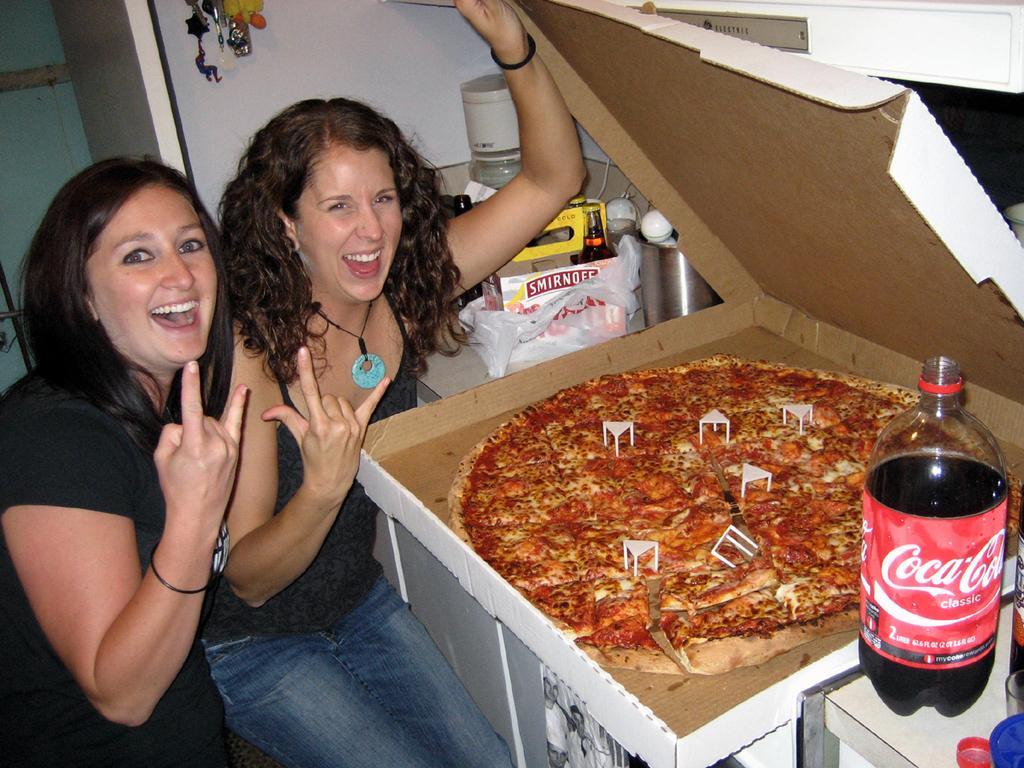Can you describe this image briefly? there is a pizza and a juice bottle. and at the left there are 2 persons wearing black t shirt. 